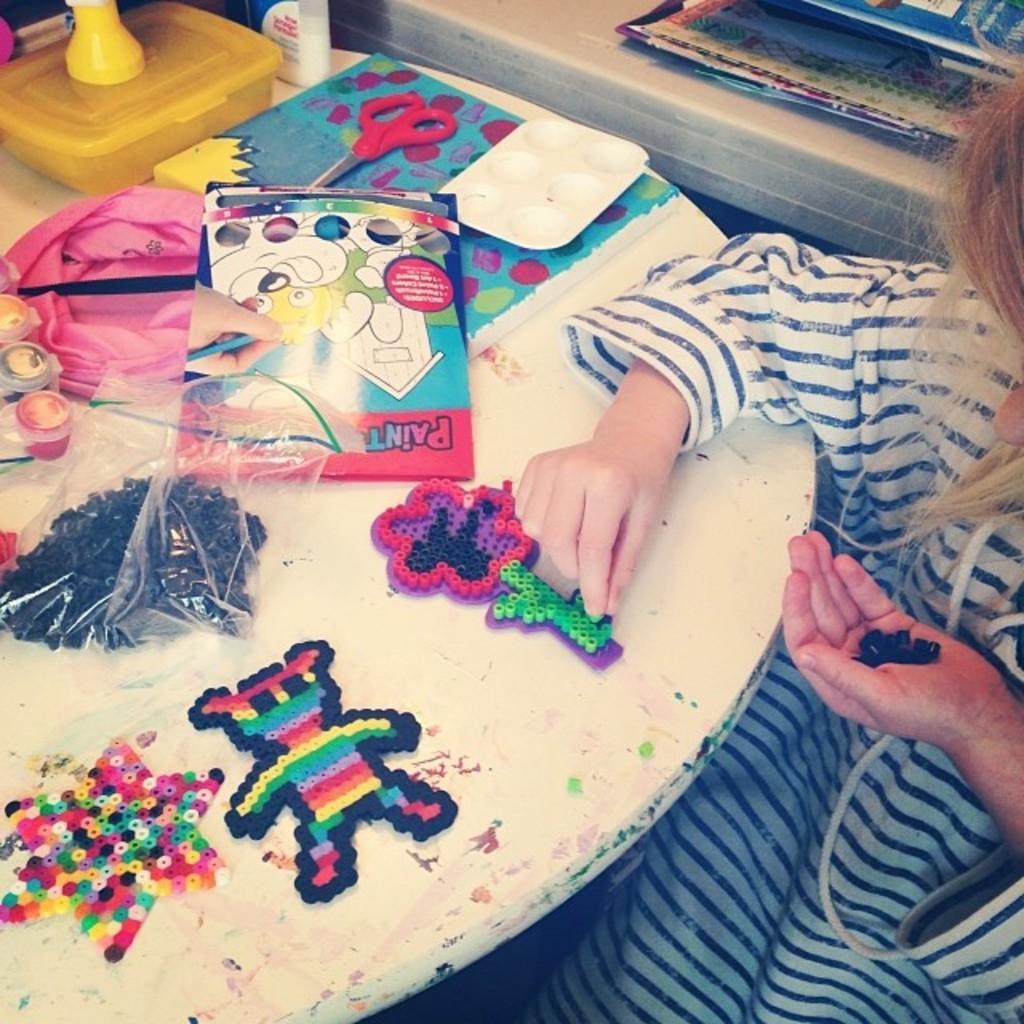Describe this image in one or two sentences. In this image there are some toys on the table and girl is sitting on the right side. 